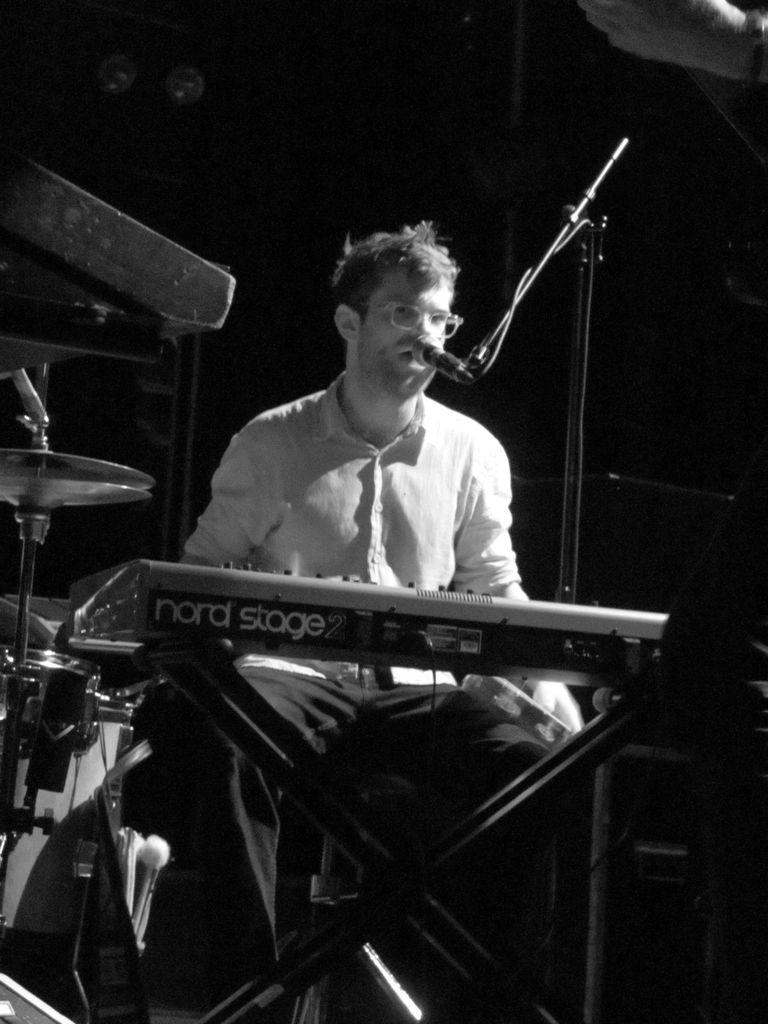What is the person in the image doing? The person is sitting in the image. What can be seen behind the person? The person is in front of a music system and a mic. What musical instrument is visible in the image? There is a drum set in the image. What color is the background of the image? The background of the image is black. What type of pets can be seen playing with a needle in the image? There are no pets or needles present in the image. 